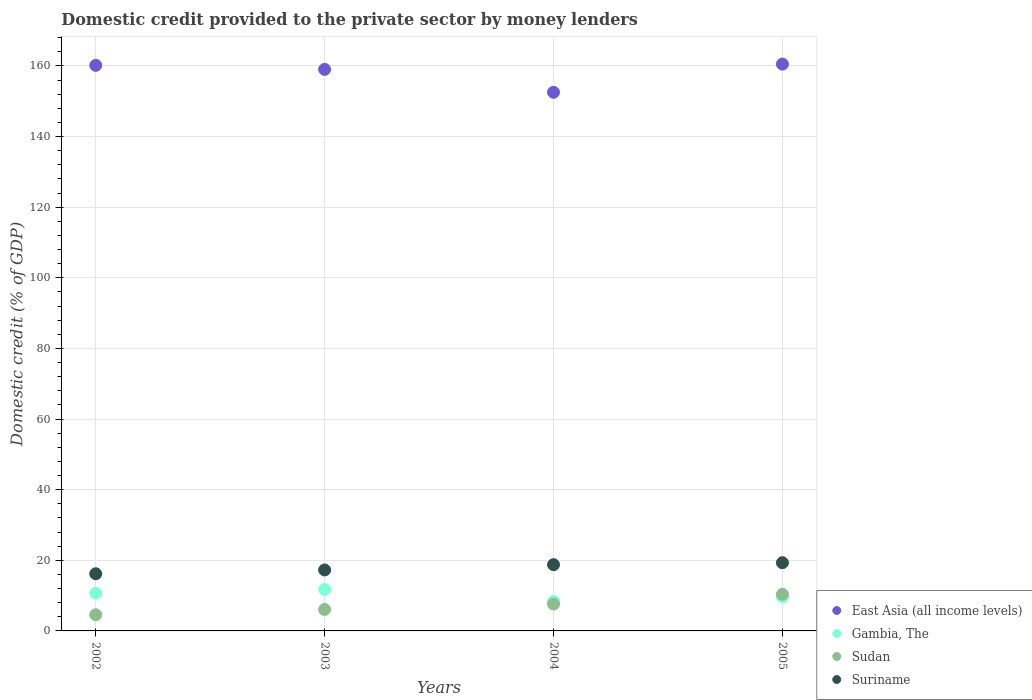Is the number of dotlines equal to the number of legend labels?
Provide a succinct answer. Yes. What is the domestic credit provided to the private sector by money lenders in East Asia (all income levels) in 2005?
Offer a very short reply. 160.51. Across all years, what is the maximum domestic credit provided to the private sector by money lenders in Suriname?
Provide a short and direct response. 19.32. Across all years, what is the minimum domestic credit provided to the private sector by money lenders in East Asia (all income levels)?
Provide a short and direct response. 152.54. In which year was the domestic credit provided to the private sector by money lenders in Gambia, The minimum?
Give a very brief answer. 2004. What is the total domestic credit provided to the private sector by money lenders in East Asia (all income levels) in the graph?
Provide a short and direct response. 632.24. What is the difference between the domestic credit provided to the private sector by money lenders in East Asia (all income levels) in 2002 and that in 2004?
Give a very brief answer. 7.63. What is the difference between the domestic credit provided to the private sector by money lenders in Gambia, The in 2004 and the domestic credit provided to the private sector by money lenders in East Asia (all income levels) in 2002?
Provide a succinct answer. -151.8. What is the average domestic credit provided to the private sector by money lenders in Sudan per year?
Your response must be concise. 7.16. In the year 2002, what is the difference between the domestic credit provided to the private sector by money lenders in East Asia (all income levels) and domestic credit provided to the private sector by money lenders in Gambia, The?
Give a very brief answer. 149.47. What is the ratio of the domestic credit provided to the private sector by money lenders in Gambia, The in 2002 to that in 2003?
Make the answer very short. 0.91. What is the difference between the highest and the second highest domestic credit provided to the private sector by money lenders in Gambia, The?
Give a very brief answer. 1.07. What is the difference between the highest and the lowest domestic credit provided to the private sector by money lenders in Suriname?
Make the answer very short. 3.13. In how many years, is the domestic credit provided to the private sector by money lenders in Suriname greater than the average domestic credit provided to the private sector by money lenders in Suriname taken over all years?
Ensure brevity in your answer.  2. Is the sum of the domestic credit provided to the private sector by money lenders in Gambia, The in 2004 and 2005 greater than the maximum domestic credit provided to the private sector by money lenders in Sudan across all years?
Provide a succinct answer. Yes. Is it the case that in every year, the sum of the domestic credit provided to the private sector by money lenders in East Asia (all income levels) and domestic credit provided to the private sector by money lenders in Sudan  is greater than the domestic credit provided to the private sector by money lenders in Suriname?
Offer a terse response. Yes. Is the domestic credit provided to the private sector by money lenders in Suriname strictly greater than the domestic credit provided to the private sector by money lenders in East Asia (all income levels) over the years?
Give a very brief answer. No. Does the graph contain any zero values?
Your answer should be compact. No. Does the graph contain grids?
Provide a succinct answer. Yes. How many legend labels are there?
Provide a short and direct response. 4. How are the legend labels stacked?
Keep it short and to the point. Vertical. What is the title of the graph?
Offer a terse response. Domestic credit provided to the private sector by money lenders. Does "Micronesia" appear as one of the legend labels in the graph?
Give a very brief answer. No. What is the label or title of the Y-axis?
Keep it short and to the point. Domestic credit (% of GDP). What is the Domestic credit (% of GDP) of East Asia (all income levels) in 2002?
Provide a succinct answer. 160.16. What is the Domestic credit (% of GDP) of Gambia, The in 2002?
Provide a short and direct response. 10.69. What is the Domestic credit (% of GDP) of Sudan in 2002?
Your answer should be very brief. 4.58. What is the Domestic credit (% of GDP) in Suriname in 2002?
Your answer should be compact. 16.19. What is the Domestic credit (% of GDP) in East Asia (all income levels) in 2003?
Give a very brief answer. 159.02. What is the Domestic credit (% of GDP) in Gambia, The in 2003?
Keep it short and to the point. 11.76. What is the Domestic credit (% of GDP) in Sudan in 2003?
Provide a succinct answer. 6.07. What is the Domestic credit (% of GDP) in Suriname in 2003?
Offer a very short reply. 17.27. What is the Domestic credit (% of GDP) of East Asia (all income levels) in 2004?
Your answer should be very brief. 152.54. What is the Domestic credit (% of GDP) in Gambia, The in 2004?
Offer a terse response. 8.36. What is the Domestic credit (% of GDP) in Sudan in 2004?
Your answer should be compact. 7.61. What is the Domestic credit (% of GDP) of Suriname in 2004?
Your answer should be compact. 18.76. What is the Domestic credit (% of GDP) of East Asia (all income levels) in 2005?
Your answer should be very brief. 160.51. What is the Domestic credit (% of GDP) in Gambia, The in 2005?
Your answer should be compact. 9.64. What is the Domestic credit (% of GDP) in Sudan in 2005?
Your answer should be very brief. 10.36. What is the Domestic credit (% of GDP) of Suriname in 2005?
Provide a succinct answer. 19.32. Across all years, what is the maximum Domestic credit (% of GDP) in East Asia (all income levels)?
Ensure brevity in your answer.  160.51. Across all years, what is the maximum Domestic credit (% of GDP) of Gambia, The?
Your response must be concise. 11.76. Across all years, what is the maximum Domestic credit (% of GDP) of Sudan?
Give a very brief answer. 10.36. Across all years, what is the maximum Domestic credit (% of GDP) in Suriname?
Provide a succinct answer. 19.32. Across all years, what is the minimum Domestic credit (% of GDP) in East Asia (all income levels)?
Your answer should be compact. 152.54. Across all years, what is the minimum Domestic credit (% of GDP) of Gambia, The?
Give a very brief answer. 8.36. Across all years, what is the minimum Domestic credit (% of GDP) in Sudan?
Provide a succinct answer. 4.58. Across all years, what is the minimum Domestic credit (% of GDP) of Suriname?
Your response must be concise. 16.19. What is the total Domestic credit (% of GDP) in East Asia (all income levels) in the graph?
Ensure brevity in your answer.  632.24. What is the total Domestic credit (% of GDP) of Gambia, The in the graph?
Offer a terse response. 40.45. What is the total Domestic credit (% of GDP) of Sudan in the graph?
Give a very brief answer. 28.62. What is the total Domestic credit (% of GDP) of Suriname in the graph?
Keep it short and to the point. 71.53. What is the difference between the Domestic credit (% of GDP) of East Asia (all income levels) in 2002 and that in 2003?
Keep it short and to the point. 1.14. What is the difference between the Domestic credit (% of GDP) in Gambia, The in 2002 and that in 2003?
Provide a short and direct response. -1.07. What is the difference between the Domestic credit (% of GDP) of Sudan in 2002 and that in 2003?
Your response must be concise. -1.49. What is the difference between the Domestic credit (% of GDP) in Suriname in 2002 and that in 2003?
Your response must be concise. -1.08. What is the difference between the Domestic credit (% of GDP) of East Asia (all income levels) in 2002 and that in 2004?
Ensure brevity in your answer.  7.63. What is the difference between the Domestic credit (% of GDP) in Gambia, The in 2002 and that in 2004?
Provide a short and direct response. 2.33. What is the difference between the Domestic credit (% of GDP) of Sudan in 2002 and that in 2004?
Offer a very short reply. -3.03. What is the difference between the Domestic credit (% of GDP) of Suriname in 2002 and that in 2004?
Give a very brief answer. -2.57. What is the difference between the Domestic credit (% of GDP) in East Asia (all income levels) in 2002 and that in 2005?
Ensure brevity in your answer.  -0.35. What is the difference between the Domestic credit (% of GDP) of Gambia, The in 2002 and that in 2005?
Provide a short and direct response. 1.05. What is the difference between the Domestic credit (% of GDP) in Sudan in 2002 and that in 2005?
Ensure brevity in your answer.  -5.79. What is the difference between the Domestic credit (% of GDP) in Suriname in 2002 and that in 2005?
Your answer should be compact. -3.13. What is the difference between the Domestic credit (% of GDP) of East Asia (all income levels) in 2003 and that in 2004?
Offer a terse response. 6.48. What is the difference between the Domestic credit (% of GDP) in Gambia, The in 2003 and that in 2004?
Your response must be concise. 3.39. What is the difference between the Domestic credit (% of GDP) of Sudan in 2003 and that in 2004?
Offer a terse response. -1.54. What is the difference between the Domestic credit (% of GDP) of Suriname in 2003 and that in 2004?
Your answer should be very brief. -1.49. What is the difference between the Domestic credit (% of GDP) of East Asia (all income levels) in 2003 and that in 2005?
Your response must be concise. -1.49. What is the difference between the Domestic credit (% of GDP) of Gambia, The in 2003 and that in 2005?
Keep it short and to the point. 2.12. What is the difference between the Domestic credit (% of GDP) of Sudan in 2003 and that in 2005?
Ensure brevity in your answer.  -4.29. What is the difference between the Domestic credit (% of GDP) in Suriname in 2003 and that in 2005?
Keep it short and to the point. -2.05. What is the difference between the Domestic credit (% of GDP) in East Asia (all income levels) in 2004 and that in 2005?
Give a very brief answer. -7.98. What is the difference between the Domestic credit (% of GDP) in Gambia, The in 2004 and that in 2005?
Provide a succinct answer. -1.27. What is the difference between the Domestic credit (% of GDP) of Sudan in 2004 and that in 2005?
Ensure brevity in your answer.  -2.75. What is the difference between the Domestic credit (% of GDP) of Suriname in 2004 and that in 2005?
Offer a very short reply. -0.56. What is the difference between the Domestic credit (% of GDP) in East Asia (all income levels) in 2002 and the Domestic credit (% of GDP) in Gambia, The in 2003?
Ensure brevity in your answer.  148.41. What is the difference between the Domestic credit (% of GDP) of East Asia (all income levels) in 2002 and the Domestic credit (% of GDP) of Sudan in 2003?
Provide a short and direct response. 154.09. What is the difference between the Domestic credit (% of GDP) in East Asia (all income levels) in 2002 and the Domestic credit (% of GDP) in Suriname in 2003?
Offer a very short reply. 142.9. What is the difference between the Domestic credit (% of GDP) of Gambia, The in 2002 and the Domestic credit (% of GDP) of Sudan in 2003?
Offer a terse response. 4.62. What is the difference between the Domestic credit (% of GDP) of Gambia, The in 2002 and the Domestic credit (% of GDP) of Suriname in 2003?
Offer a terse response. -6.58. What is the difference between the Domestic credit (% of GDP) in Sudan in 2002 and the Domestic credit (% of GDP) in Suriname in 2003?
Give a very brief answer. -12.69. What is the difference between the Domestic credit (% of GDP) in East Asia (all income levels) in 2002 and the Domestic credit (% of GDP) in Gambia, The in 2004?
Make the answer very short. 151.8. What is the difference between the Domestic credit (% of GDP) in East Asia (all income levels) in 2002 and the Domestic credit (% of GDP) in Sudan in 2004?
Offer a very short reply. 152.55. What is the difference between the Domestic credit (% of GDP) in East Asia (all income levels) in 2002 and the Domestic credit (% of GDP) in Suriname in 2004?
Offer a very short reply. 141.41. What is the difference between the Domestic credit (% of GDP) of Gambia, The in 2002 and the Domestic credit (% of GDP) of Sudan in 2004?
Provide a succinct answer. 3.08. What is the difference between the Domestic credit (% of GDP) in Gambia, The in 2002 and the Domestic credit (% of GDP) in Suriname in 2004?
Make the answer very short. -8.07. What is the difference between the Domestic credit (% of GDP) of Sudan in 2002 and the Domestic credit (% of GDP) of Suriname in 2004?
Offer a very short reply. -14.18. What is the difference between the Domestic credit (% of GDP) in East Asia (all income levels) in 2002 and the Domestic credit (% of GDP) in Gambia, The in 2005?
Ensure brevity in your answer.  150.53. What is the difference between the Domestic credit (% of GDP) of East Asia (all income levels) in 2002 and the Domestic credit (% of GDP) of Sudan in 2005?
Provide a succinct answer. 149.8. What is the difference between the Domestic credit (% of GDP) of East Asia (all income levels) in 2002 and the Domestic credit (% of GDP) of Suriname in 2005?
Make the answer very short. 140.85. What is the difference between the Domestic credit (% of GDP) of Gambia, The in 2002 and the Domestic credit (% of GDP) of Sudan in 2005?
Make the answer very short. 0.33. What is the difference between the Domestic credit (% of GDP) of Gambia, The in 2002 and the Domestic credit (% of GDP) of Suriname in 2005?
Provide a short and direct response. -8.63. What is the difference between the Domestic credit (% of GDP) of Sudan in 2002 and the Domestic credit (% of GDP) of Suriname in 2005?
Make the answer very short. -14.74. What is the difference between the Domestic credit (% of GDP) of East Asia (all income levels) in 2003 and the Domestic credit (% of GDP) of Gambia, The in 2004?
Your answer should be very brief. 150.66. What is the difference between the Domestic credit (% of GDP) in East Asia (all income levels) in 2003 and the Domestic credit (% of GDP) in Sudan in 2004?
Offer a very short reply. 151.41. What is the difference between the Domestic credit (% of GDP) of East Asia (all income levels) in 2003 and the Domestic credit (% of GDP) of Suriname in 2004?
Give a very brief answer. 140.26. What is the difference between the Domestic credit (% of GDP) in Gambia, The in 2003 and the Domestic credit (% of GDP) in Sudan in 2004?
Ensure brevity in your answer.  4.15. What is the difference between the Domestic credit (% of GDP) of Gambia, The in 2003 and the Domestic credit (% of GDP) of Suriname in 2004?
Make the answer very short. -7. What is the difference between the Domestic credit (% of GDP) of Sudan in 2003 and the Domestic credit (% of GDP) of Suriname in 2004?
Give a very brief answer. -12.68. What is the difference between the Domestic credit (% of GDP) of East Asia (all income levels) in 2003 and the Domestic credit (% of GDP) of Gambia, The in 2005?
Your response must be concise. 149.38. What is the difference between the Domestic credit (% of GDP) of East Asia (all income levels) in 2003 and the Domestic credit (% of GDP) of Sudan in 2005?
Keep it short and to the point. 148.66. What is the difference between the Domestic credit (% of GDP) of East Asia (all income levels) in 2003 and the Domestic credit (% of GDP) of Suriname in 2005?
Offer a terse response. 139.7. What is the difference between the Domestic credit (% of GDP) in Gambia, The in 2003 and the Domestic credit (% of GDP) in Sudan in 2005?
Offer a terse response. 1.39. What is the difference between the Domestic credit (% of GDP) of Gambia, The in 2003 and the Domestic credit (% of GDP) of Suriname in 2005?
Your response must be concise. -7.56. What is the difference between the Domestic credit (% of GDP) in Sudan in 2003 and the Domestic credit (% of GDP) in Suriname in 2005?
Provide a short and direct response. -13.24. What is the difference between the Domestic credit (% of GDP) in East Asia (all income levels) in 2004 and the Domestic credit (% of GDP) in Gambia, The in 2005?
Provide a succinct answer. 142.9. What is the difference between the Domestic credit (% of GDP) of East Asia (all income levels) in 2004 and the Domestic credit (% of GDP) of Sudan in 2005?
Provide a short and direct response. 142.17. What is the difference between the Domestic credit (% of GDP) of East Asia (all income levels) in 2004 and the Domestic credit (% of GDP) of Suriname in 2005?
Keep it short and to the point. 133.22. What is the difference between the Domestic credit (% of GDP) in Gambia, The in 2004 and the Domestic credit (% of GDP) in Sudan in 2005?
Your answer should be compact. -2. What is the difference between the Domestic credit (% of GDP) in Gambia, The in 2004 and the Domestic credit (% of GDP) in Suriname in 2005?
Your answer should be compact. -10.95. What is the difference between the Domestic credit (% of GDP) of Sudan in 2004 and the Domestic credit (% of GDP) of Suriname in 2005?
Your answer should be compact. -11.71. What is the average Domestic credit (% of GDP) of East Asia (all income levels) per year?
Your answer should be compact. 158.06. What is the average Domestic credit (% of GDP) of Gambia, The per year?
Offer a very short reply. 10.11. What is the average Domestic credit (% of GDP) in Sudan per year?
Your answer should be very brief. 7.16. What is the average Domestic credit (% of GDP) of Suriname per year?
Your answer should be very brief. 17.88. In the year 2002, what is the difference between the Domestic credit (% of GDP) of East Asia (all income levels) and Domestic credit (% of GDP) of Gambia, The?
Your answer should be compact. 149.47. In the year 2002, what is the difference between the Domestic credit (% of GDP) in East Asia (all income levels) and Domestic credit (% of GDP) in Sudan?
Give a very brief answer. 155.59. In the year 2002, what is the difference between the Domestic credit (% of GDP) in East Asia (all income levels) and Domestic credit (% of GDP) in Suriname?
Provide a short and direct response. 143.97. In the year 2002, what is the difference between the Domestic credit (% of GDP) in Gambia, The and Domestic credit (% of GDP) in Sudan?
Provide a succinct answer. 6.11. In the year 2002, what is the difference between the Domestic credit (% of GDP) in Gambia, The and Domestic credit (% of GDP) in Suriname?
Keep it short and to the point. -5.5. In the year 2002, what is the difference between the Domestic credit (% of GDP) of Sudan and Domestic credit (% of GDP) of Suriname?
Provide a succinct answer. -11.61. In the year 2003, what is the difference between the Domestic credit (% of GDP) in East Asia (all income levels) and Domestic credit (% of GDP) in Gambia, The?
Provide a short and direct response. 147.26. In the year 2003, what is the difference between the Domestic credit (% of GDP) in East Asia (all income levels) and Domestic credit (% of GDP) in Sudan?
Give a very brief answer. 152.95. In the year 2003, what is the difference between the Domestic credit (% of GDP) of East Asia (all income levels) and Domestic credit (% of GDP) of Suriname?
Provide a succinct answer. 141.75. In the year 2003, what is the difference between the Domestic credit (% of GDP) of Gambia, The and Domestic credit (% of GDP) of Sudan?
Ensure brevity in your answer.  5.69. In the year 2003, what is the difference between the Domestic credit (% of GDP) of Gambia, The and Domestic credit (% of GDP) of Suriname?
Your answer should be very brief. -5.51. In the year 2003, what is the difference between the Domestic credit (% of GDP) in Sudan and Domestic credit (% of GDP) in Suriname?
Give a very brief answer. -11.2. In the year 2004, what is the difference between the Domestic credit (% of GDP) of East Asia (all income levels) and Domestic credit (% of GDP) of Gambia, The?
Your response must be concise. 144.17. In the year 2004, what is the difference between the Domestic credit (% of GDP) in East Asia (all income levels) and Domestic credit (% of GDP) in Sudan?
Offer a very short reply. 144.93. In the year 2004, what is the difference between the Domestic credit (% of GDP) of East Asia (all income levels) and Domestic credit (% of GDP) of Suriname?
Give a very brief answer. 133.78. In the year 2004, what is the difference between the Domestic credit (% of GDP) in Gambia, The and Domestic credit (% of GDP) in Sudan?
Make the answer very short. 0.75. In the year 2004, what is the difference between the Domestic credit (% of GDP) of Gambia, The and Domestic credit (% of GDP) of Suriname?
Keep it short and to the point. -10.39. In the year 2004, what is the difference between the Domestic credit (% of GDP) of Sudan and Domestic credit (% of GDP) of Suriname?
Ensure brevity in your answer.  -11.15. In the year 2005, what is the difference between the Domestic credit (% of GDP) in East Asia (all income levels) and Domestic credit (% of GDP) in Gambia, The?
Provide a short and direct response. 150.88. In the year 2005, what is the difference between the Domestic credit (% of GDP) in East Asia (all income levels) and Domestic credit (% of GDP) in Sudan?
Provide a succinct answer. 150.15. In the year 2005, what is the difference between the Domestic credit (% of GDP) of East Asia (all income levels) and Domestic credit (% of GDP) of Suriname?
Give a very brief answer. 141.2. In the year 2005, what is the difference between the Domestic credit (% of GDP) of Gambia, The and Domestic credit (% of GDP) of Sudan?
Your answer should be very brief. -0.73. In the year 2005, what is the difference between the Domestic credit (% of GDP) of Gambia, The and Domestic credit (% of GDP) of Suriname?
Ensure brevity in your answer.  -9.68. In the year 2005, what is the difference between the Domestic credit (% of GDP) of Sudan and Domestic credit (% of GDP) of Suriname?
Offer a very short reply. -8.95. What is the ratio of the Domestic credit (% of GDP) in Gambia, The in 2002 to that in 2003?
Provide a succinct answer. 0.91. What is the ratio of the Domestic credit (% of GDP) of Sudan in 2002 to that in 2003?
Offer a terse response. 0.75. What is the ratio of the Domestic credit (% of GDP) of Suriname in 2002 to that in 2003?
Make the answer very short. 0.94. What is the ratio of the Domestic credit (% of GDP) in East Asia (all income levels) in 2002 to that in 2004?
Your response must be concise. 1.05. What is the ratio of the Domestic credit (% of GDP) in Gambia, The in 2002 to that in 2004?
Your response must be concise. 1.28. What is the ratio of the Domestic credit (% of GDP) of Sudan in 2002 to that in 2004?
Ensure brevity in your answer.  0.6. What is the ratio of the Domestic credit (% of GDP) in Suriname in 2002 to that in 2004?
Offer a terse response. 0.86. What is the ratio of the Domestic credit (% of GDP) in East Asia (all income levels) in 2002 to that in 2005?
Give a very brief answer. 1. What is the ratio of the Domestic credit (% of GDP) in Gambia, The in 2002 to that in 2005?
Your answer should be compact. 1.11. What is the ratio of the Domestic credit (% of GDP) in Sudan in 2002 to that in 2005?
Make the answer very short. 0.44. What is the ratio of the Domestic credit (% of GDP) of Suriname in 2002 to that in 2005?
Provide a succinct answer. 0.84. What is the ratio of the Domestic credit (% of GDP) of East Asia (all income levels) in 2003 to that in 2004?
Your answer should be very brief. 1.04. What is the ratio of the Domestic credit (% of GDP) of Gambia, The in 2003 to that in 2004?
Give a very brief answer. 1.41. What is the ratio of the Domestic credit (% of GDP) of Sudan in 2003 to that in 2004?
Ensure brevity in your answer.  0.8. What is the ratio of the Domestic credit (% of GDP) of Suriname in 2003 to that in 2004?
Offer a terse response. 0.92. What is the ratio of the Domestic credit (% of GDP) in East Asia (all income levels) in 2003 to that in 2005?
Ensure brevity in your answer.  0.99. What is the ratio of the Domestic credit (% of GDP) in Gambia, The in 2003 to that in 2005?
Ensure brevity in your answer.  1.22. What is the ratio of the Domestic credit (% of GDP) of Sudan in 2003 to that in 2005?
Give a very brief answer. 0.59. What is the ratio of the Domestic credit (% of GDP) of Suriname in 2003 to that in 2005?
Provide a succinct answer. 0.89. What is the ratio of the Domestic credit (% of GDP) of East Asia (all income levels) in 2004 to that in 2005?
Your answer should be compact. 0.95. What is the ratio of the Domestic credit (% of GDP) in Gambia, The in 2004 to that in 2005?
Your answer should be compact. 0.87. What is the ratio of the Domestic credit (% of GDP) of Sudan in 2004 to that in 2005?
Ensure brevity in your answer.  0.73. What is the difference between the highest and the second highest Domestic credit (% of GDP) in East Asia (all income levels)?
Give a very brief answer. 0.35. What is the difference between the highest and the second highest Domestic credit (% of GDP) in Gambia, The?
Offer a very short reply. 1.07. What is the difference between the highest and the second highest Domestic credit (% of GDP) in Sudan?
Your answer should be compact. 2.75. What is the difference between the highest and the second highest Domestic credit (% of GDP) of Suriname?
Provide a short and direct response. 0.56. What is the difference between the highest and the lowest Domestic credit (% of GDP) of East Asia (all income levels)?
Provide a succinct answer. 7.98. What is the difference between the highest and the lowest Domestic credit (% of GDP) in Gambia, The?
Give a very brief answer. 3.39. What is the difference between the highest and the lowest Domestic credit (% of GDP) of Sudan?
Provide a succinct answer. 5.79. What is the difference between the highest and the lowest Domestic credit (% of GDP) in Suriname?
Offer a terse response. 3.13. 